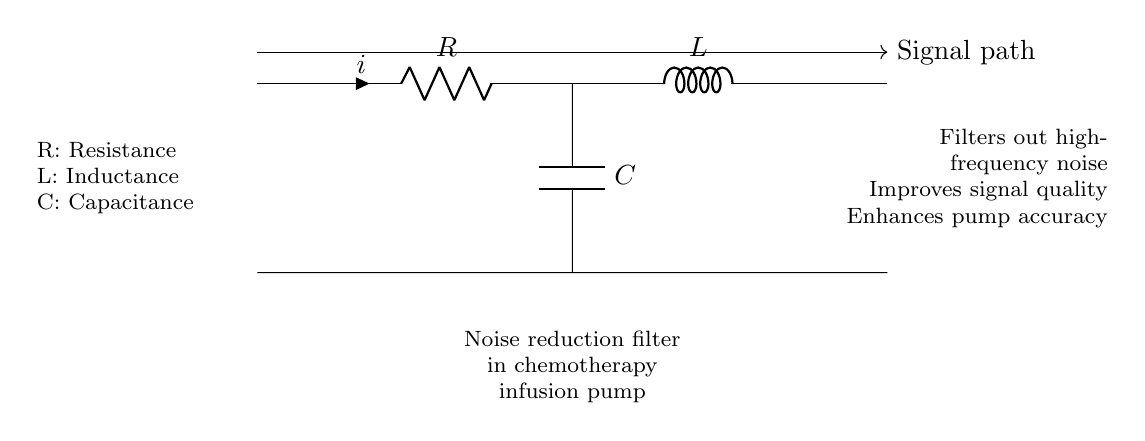What components are present in the circuit? The circuit has a resistor, inductor, and capacitor. These are the basic components commonly used in electrical circuits to manage current and voltage.
Answer: Resistor, Inductor, Capacitor What is the purpose of the noise reduction filter? The filter is designed to filter out high-frequency noise, thereby improving the quality of the signal in the chemotherapy infusion pump. This is crucial for ensuring accurate medication delivery.
Answer: Improve signal quality What does the 'R' represent in the circuit? 'R' indicates the resistance value in ohms, which determines how much the conductor resists the flow of current. In this context, it specifically refers to the resistor's function in the circuit.
Answer: Resistance How does the combination of R, L, and C affect the signal? The combination creates a filter that can attenuate certain frequencies. Specifically, R affects the damping, L stores energy in a magnetic field, and C stores energy in an electric field, together shaping the filter’s response to signals.
Answer: Attenuates certain frequencies What does the 'C' component do in this circuit? 'C' refers to the capacitor, which stores and releases electrical energy. In this configuration, it helps in smoothing out the output voltage by filtering high-frequency noise from the signal.
Answer: Stores electrical energy What is the significance of the signal path in the circuit? The signal path indicates where the input signal flows through the circuit components. Understanding this path is essential for analyzing how the noise reduction filter processes the signal before reaching the chemotherapy infusion pump.
Answer: Processing signal flow 